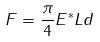<formula> <loc_0><loc_0><loc_500><loc_500>F = \frac { \pi } { 4 } E ^ { * } L d</formula> 